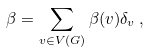Convert formula to latex. <formula><loc_0><loc_0><loc_500><loc_500>\beta = \sum _ { v \in V ( G ) } \beta ( v ) \delta _ { v } \, ,</formula> 